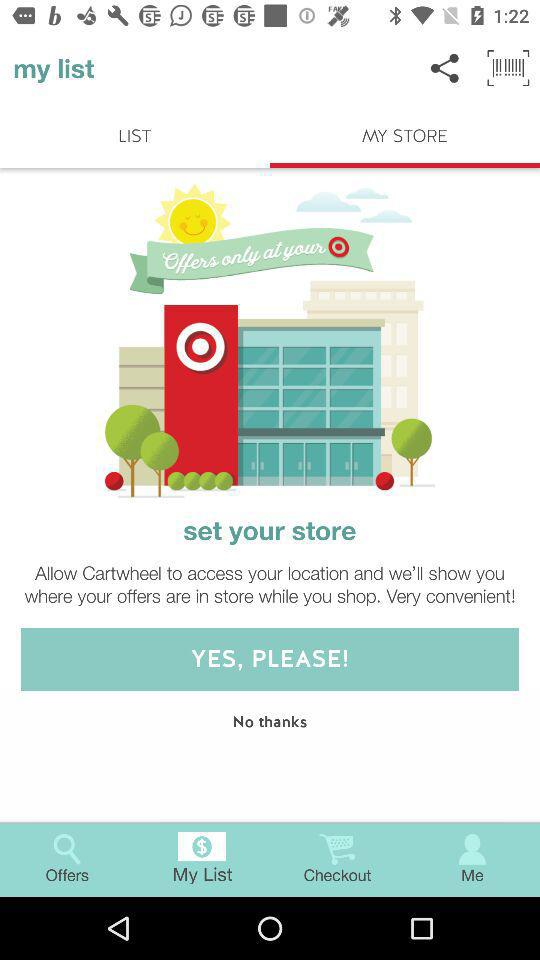Which tab is selected? The selected tabs are "MY STORE" and "My List". 